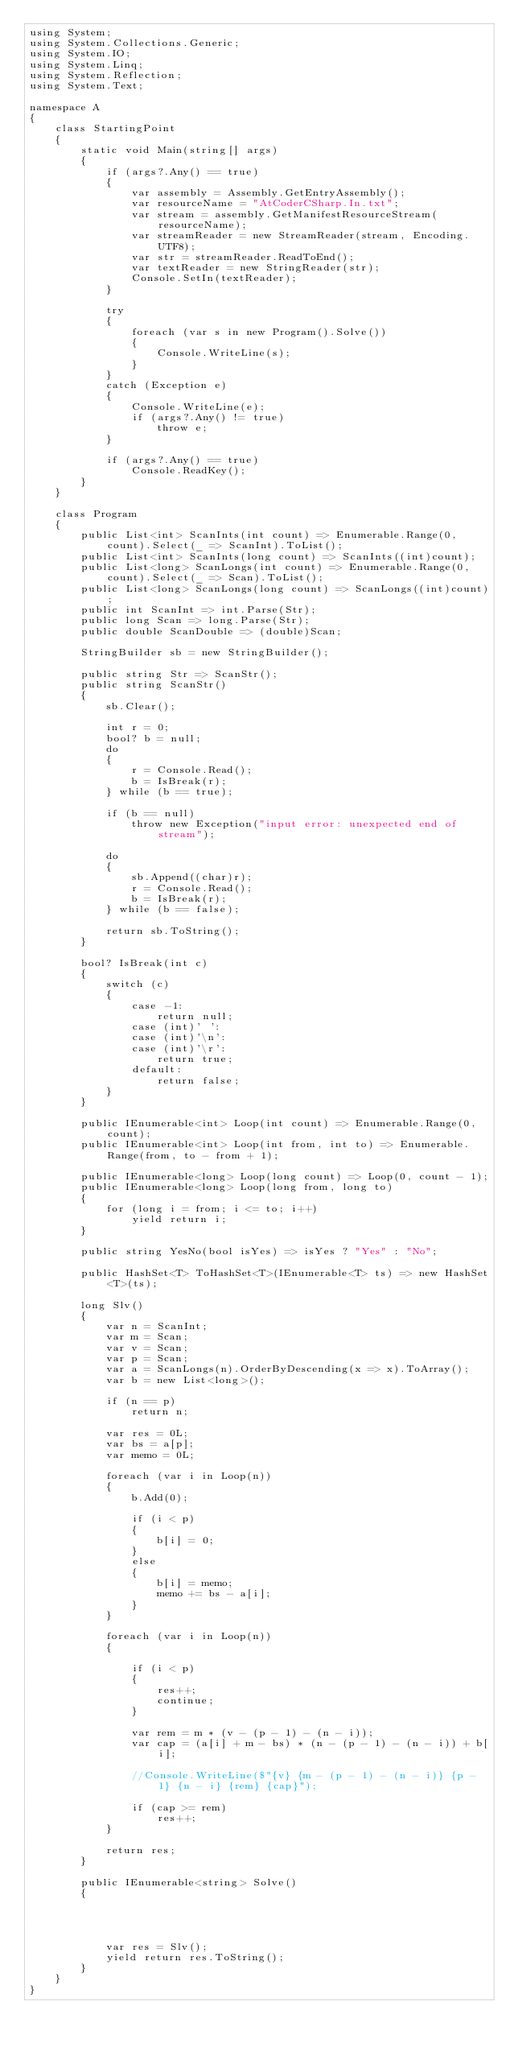Convert code to text. <code><loc_0><loc_0><loc_500><loc_500><_C#_>using System;
using System.Collections.Generic;
using System.IO;
using System.Linq;
using System.Reflection;
using System.Text;

namespace A
{
    class StartingPoint
    {
        static void Main(string[] args)
        {
            if (args?.Any() == true)
            {
                var assembly = Assembly.GetEntryAssembly();
                var resourceName = "AtCoderCSharp.In.txt";
                var stream = assembly.GetManifestResourceStream(resourceName);
                var streamReader = new StreamReader(stream, Encoding.UTF8);
                var str = streamReader.ReadToEnd();
                var textReader = new StringReader(str);
                Console.SetIn(textReader);
            }

            try
            {
                foreach (var s in new Program().Solve())
                {
                    Console.WriteLine(s);
                }
            }
            catch (Exception e)
            {
                Console.WriteLine(e);
                if (args?.Any() != true)
                    throw e;
            }

            if (args?.Any() == true)
                Console.ReadKey();
        }
    }

    class Program
    {
        public List<int> ScanInts(int count) => Enumerable.Range(0, count).Select(_ => ScanInt).ToList();
        public List<int> ScanInts(long count) => ScanInts((int)count);
        public List<long> ScanLongs(int count) => Enumerable.Range(0, count).Select(_ => Scan).ToList();
        public List<long> ScanLongs(long count) => ScanLongs((int)count);
        public int ScanInt => int.Parse(Str);
        public long Scan => long.Parse(Str);
        public double ScanDouble => (double)Scan;

        StringBuilder sb = new StringBuilder();

        public string Str => ScanStr();
        public string ScanStr()
        {
            sb.Clear();

            int r = 0;
            bool? b = null;
            do
            {
                r = Console.Read();
                b = IsBreak(r);
            } while (b == true);

            if (b == null)
                throw new Exception("input error: unexpected end of stream");

            do
            {
                sb.Append((char)r);
                r = Console.Read();
                b = IsBreak(r);
            } while (b == false);

            return sb.ToString();
        }

        bool? IsBreak(int c)
        {
            switch (c)
            {
                case -1:
                    return null;
                case (int)' ':
                case (int)'\n':
                case (int)'\r':
                    return true;
                default:
                    return false;
            }
        }

        public IEnumerable<int> Loop(int count) => Enumerable.Range(0, count);
        public IEnumerable<int> Loop(int from, int to) => Enumerable.Range(from, to - from + 1);

        public IEnumerable<long> Loop(long count) => Loop(0, count - 1);
        public IEnumerable<long> Loop(long from, long to)
        {
            for (long i = from; i <= to; i++)
                yield return i;
        }

        public string YesNo(bool isYes) => isYes ? "Yes" : "No";

        public HashSet<T> ToHashSet<T>(IEnumerable<T> ts) => new HashSet<T>(ts);

        long Slv()
        {
            var n = ScanInt;
            var m = Scan;
            var v = Scan;
            var p = Scan;
            var a = ScanLongs(n).OrderByDescending(x => x).ToArray();
            var b = new List<long>();

            if (n == p)
                return n;

            var res = 0L;
            var bs = a[p];
            var memo = 0L;

            foreach (var i in Loop(n))
            {
                b.Add(0);

                if (i < p)
                {
                    b[i] = 0;
                }
                else
                {
                    b[i] = memo;
                    memo += bs - a[i];
                }
            }

            foreach (var i in Loop(n))
            {

                if (i < p)
                {
                    res++;
                    continue;
                }

                var rem = m * (v - (p - 1) - (n - i));
                var cap = (a[i] + m - bs) * (n - (p - 1) - (n - i)) + b[i];

                //Console.WriteLine($"{v} {m - (p - 1) - (n - i)} {p - 1} {n - i} {rem} {cap}");

                if (cap >= rem)
                    res++;
            }

            return res;
        }

        public IEnumerable<string> Solve()
        {




            var res = Slv();
            yield return res.ToString();
        }
    }
}</code> 